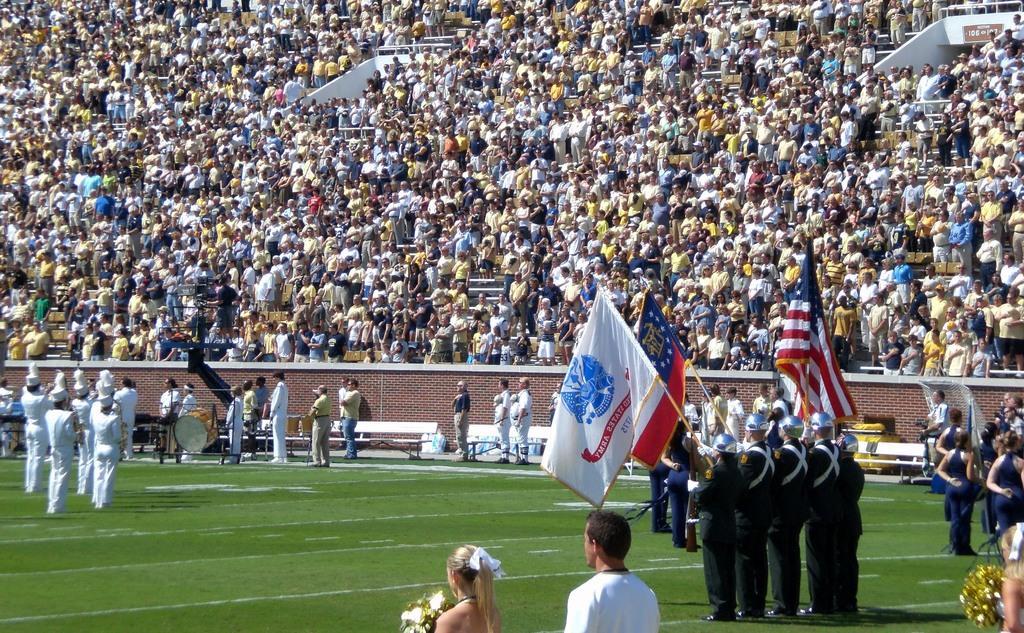In one or two sentences, can you explain what this image depicts? In the picture I can see a few people wearing the black color clothes and they are holding the flag poles in their hands. I can see a woman holding the flowers and she is at the bottom of the picture and there is a man beside her. I can see a few people wearing the white clothes and they are playing the musical instruments. In the background, I can see the spectators. 